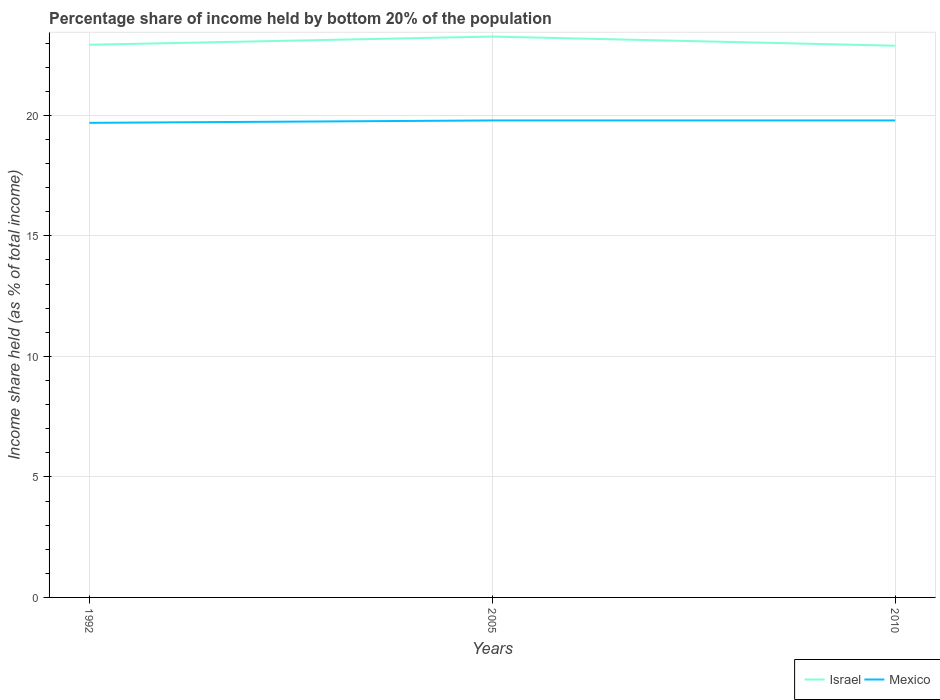Does the line corresponding to Mexico intersect with the line corresponding to Israel?
Provide a short and direct response. No. Across all years, what is the maximum share of income held by bottom 20% of the population in Mexico?
Make the answer very short. 19.69. In which year was the share of income held by bottom 20% of the population in Mexico maximum?
Offer a terse response. 1992. What is the total share of income held by bottom 20% of the population in Mexico in the graph?
Ensure brevity in your answer.  -0.1. What is the difference between the highest and the second highest share of income held by bottom 20% of the population in Mexico?
Offer a very short reply. 0.1. What is the difference between the highest and the lowest share of income held by bottom 20% of the population in Mexico?
Offer a terse response. 2. What is the difference between two consecutive major ticks on the Y-axis?
Your answer should be compact. 5. Are the values on the major ticks of Y-axis written in scientific E-notation?
Give a very brief answer. No. How many legend labels are there?
Offer a very short reply. 2. How are the legend labels stacked?
Your answer should be compact. Horizontal. What is the title of the graph?
Your answer should be very brief. Percentage share of income held by bottom 20% of the population. Does "Cayman Islands" appear as one of the legend labels in the graph?
Your answer should be very brief. No. What is the label or title of the X-axis?
Ensure brevity in your answer.  Years. What is the label or title of the Y-axis?
Keep it short and to the point. Income share held (as % of total income). What is the Income share held (as % of total income) of Israel in 1992?
Make the answer very short. 22.93. What is the Income share held (as % of total income) in Mexico in 1992?
Provide a short and direct response. 19.69. What is the Income share held (as % of total income) in Israel in 2005?
Give a very brief answer. 23.27. What is the Income share held (as % of total income) of Mexico in 2005?
Your answer should be compact. 19.79. What is the Income share held (as % of total income) in Israel in 2010?
Ensure brevity in your answer.  22.89. What is the Income share held (as % of total income) in Mexico in 2010?
Ensure brevity in your answer.  19.79. Across all years, what is the maximum Income share held (as % of total income) of Israel?
Make the answer very short. 23.27. Across all years, what is the maximum Income share held (as % of total income) of Mexico?
Offer a terse response. 19.79. Across all years, what is the minimum Income share held (as % of total income) in Israel?
Provide a short and direct response. 22.89. Across all years, what is the minimum Income share held (as % of total income) of Mexico?
Ensure brevity in your answer.  19.69. What is the total Income share held (as % of total income) of Israel in the graph?
Provide a succinct answer. 69.09. What is the total Income share held (as % of total income) of Mexico in the graph?
Keep it short and to the point. 59.27. What is the difference between the Income share held (as % of total income) of Israel in 1992 and that in 2005?
Provide a short and direct response. -0.34. What is the difference between the Income share held (as % of total income) in Mexico in 1992 and that in 2010?
Your answer should be compact. -0.1. What is the difference between the Income share held (as % of total income) of Israel in 2005 and that in 2010?
Offer a very short reply. 0.38. What is the difference between the Income share held (as % of total income) in Israel in 1992 and the Income share held (as % of total income) in Mexico in 2005?
Offer a terse response. 3.14. What is the difference between the Income share held (as % of total income) of Israel in 1992 and the Income share held (as % of total income) of Mexico in 2010?
Offer a terse response. 3.14. What is the difference between the Income share held (as % of total income) in Israel in 2005 and the Income share held (as % of total income) in Mexico in 2010?
Give a very brief answer. 3.48. What is the average Income share held (as % of total income) in Israel per year?
Your answer should be very brief. 23.03. What is the average Income share held (as % of total income) of Mexico per year?
Your answer should be compact. 19.76. In the year 1992, what is the difference between the Income share held (as % of total income) in Israel and Income share held (as % of total income) in Mexico?
Give a very brief answer. 3.24. In the year 2005, what is the difference between the Income share held (as % of total income) of Israel and Income share held (as % of total income) of Mexico?
Ensure brevity in your answer.  3.48. In the year 2010, what is the difference between the Income share held (as % of total income) in Israel and Income share held (as % of total income) in Mexico?
Ensure brevity in your answer.  3.1. What is the ratio of the Income share held (as % of total income) of Israel in 1992 to that in 2005?
Provide a succinct answer. 0.99. What is the ratio of the Income share held (as % of total income) in Mexico in 1992 to that in 2005?
Your response must be concise. 0.99. What is the ratio of the Income share held (as % of total income) in Israel in 1992 to that in 2010?
Your answer should be very brief. 1. What is the ratio of the Income share held (as % of total income) in Israel in 2005 to that in 2010?
Give a very brief answer. 1.02. What is the ratio of the Income share held (as % of total income) of Mexico in 2005 to that in 2010?
Offer a very short reply. 1. What is the difference between the highest and the second highest Income share held (as % of total income) of Israel?
Offer a very short reply. 0.34. What is the difference between the highest and the second highest Income share held (as % of total income) of Mexico?
Provide a succinct answer. 0. What is the difference between the highest and the lowest Income share held (as % of total income) of Israel?
Provide a succinct answer. 0.38. What is the difference between the highest and the lowest Income share held (as % of total income) of Mexico?
Keep it short and to the point. 0.1. 